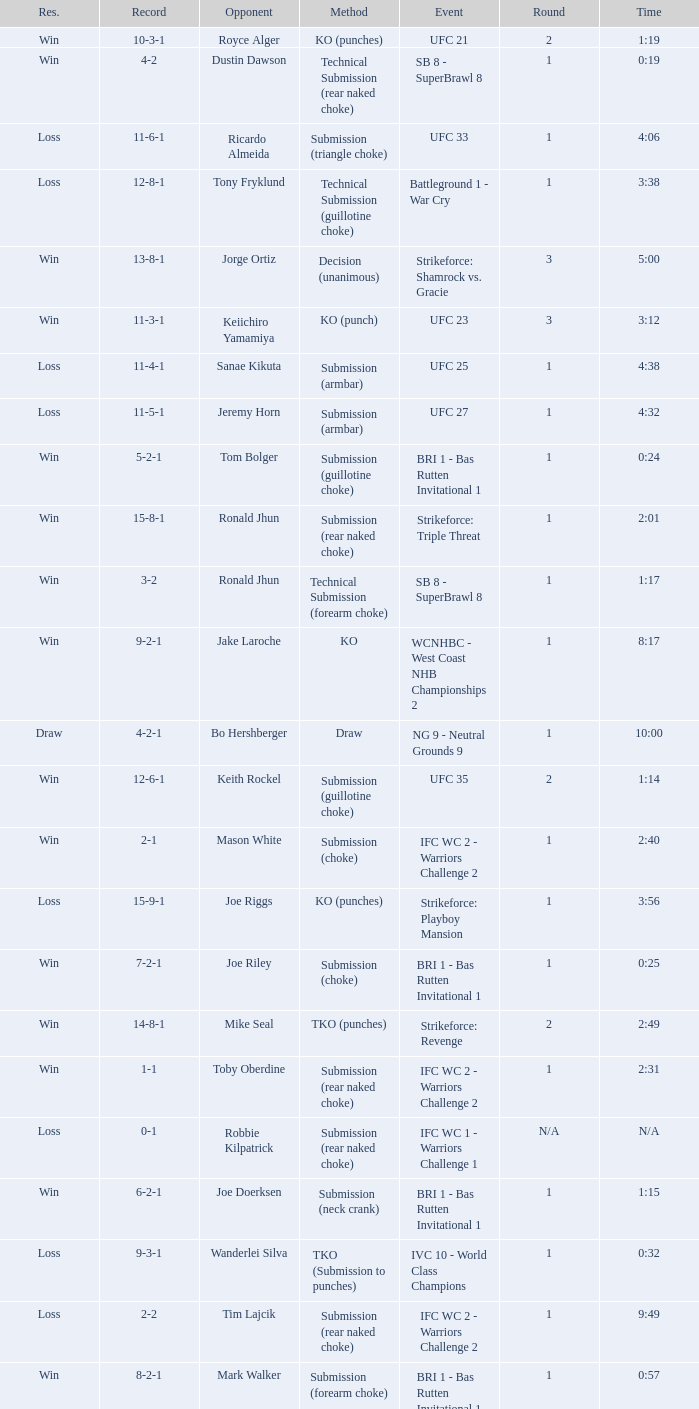Who was the opponent when the fight had a time of 2:01? Ronald Jhun. 